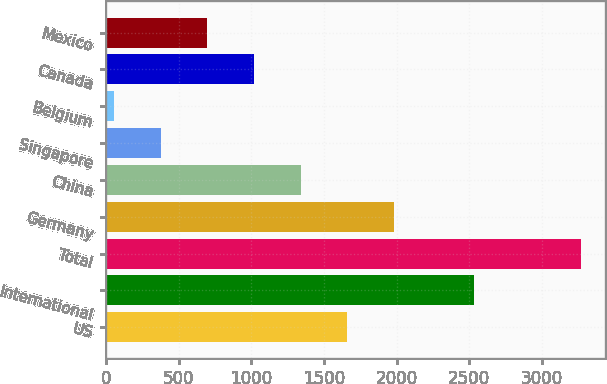Convert chart to OTSL. <chart><loc_0><loc_0><loc_500><loc_500><bar_chart><fcel>US<fcel>International<fcel>Total<fcel>Germany<fcel>China<fcel>Singapore<fcel>Belgium<fcel>Canada<fcel>Mexico<nl><fcel>1661<fcel>2534<fcel>3269<fcel>1982.6<fcel>1339.4<fcel>374.6<fcel>53<fcel>1017.8<fcel>696.2<nl></chart> 